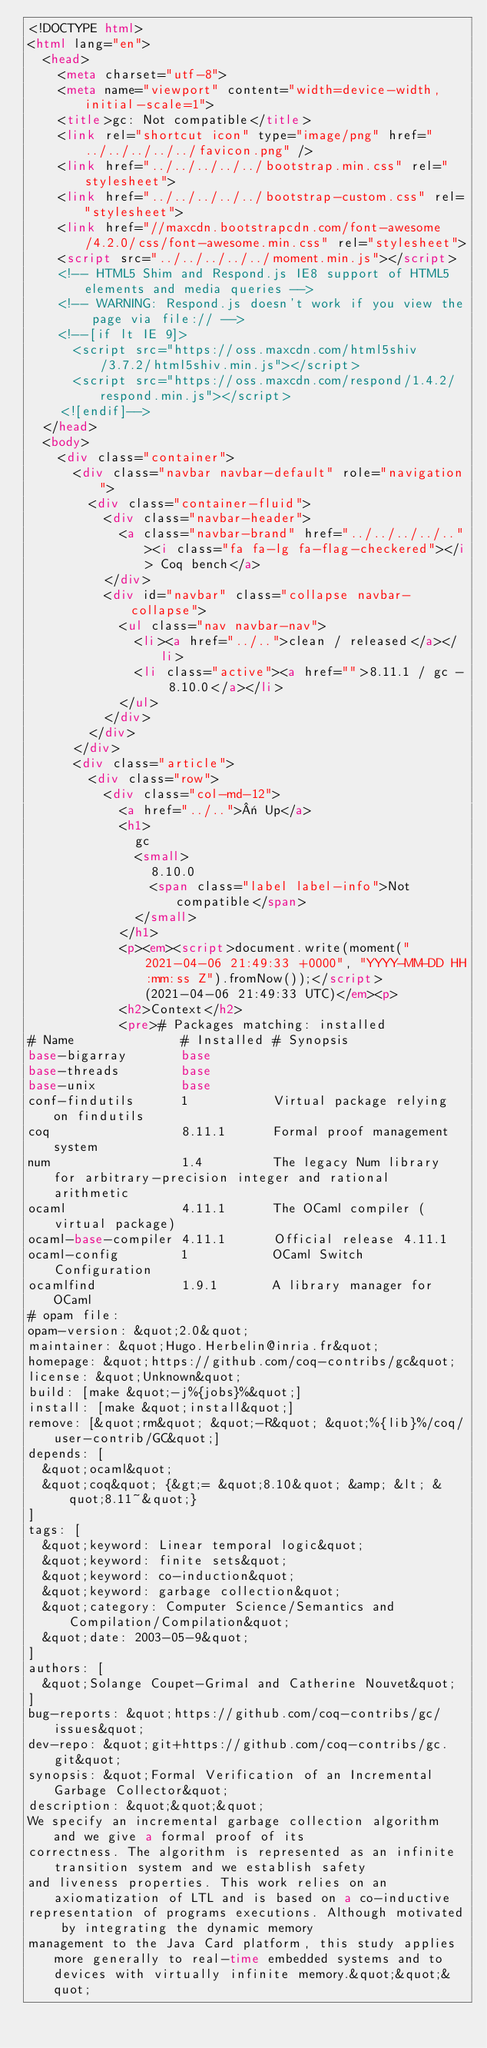<code> <loc_0><loc_0><loc_500><loc_500><_HTML_><!DOCTYPE html>
<html lang="en">
  <head>
    <meta charset="utf-8">
    <meta name="viewport" content="width=device-width, initial-scale=1">
    <title>gc: Not compatible</title>
    <link rel="shortcut icon" type="image/png" href="../../../../../favicon.png" />
    <link href="../../../../../bootstrap.min.css" rel="stylesheet">
    <link href="../../../../../bootstrap-custom.css" rel="stylesheet">
    <link href="//maxcdn.bootstrapcdn.com/font-awesome/4.2.0/css/font-awesome.min.css" rel="stylesheet">
    <script src="../../../../../moment.min.js"></script>
    <!-- HTML5 Shim and Respond.js IE8 support of HTML5 elements and media queries -->
    <!-- WARNING: Respond.js doesn't work if you view the page via file:// -->
    <!--[if lt IE 9]>
      <script src="https://oss.maxcdn.com/html5shiv/3.7.2/html5shiv.min.js"></script>
      <script src="https://oss.maxcdn.com/respond/1.4.2/respond.min.js"></script>
    <![endif]-->
  </head>
  <body>
    <div class="container">
      <div class="navbar navbar-default" role="navigation">
        <div class="container-fluid">
          <div class="navbar-header">
            <a class="navbar-brand" href="../../../../.."><i class="fa fa-lg fa-flag-checkered"></i> Coq bench</a>
          </div>
          <div id="navbar" class="collapse navbar-collapse">
            <ul class="nav navbar-nav">
              <li><a href="../..">clean / released</a></li>
              <li class="active"><a href="">8.11.1 / gc - 8.10.0</a></li>
            </ul>
          </div>
        </div>
      </div>
      <div class="article">
        <div class="row">
          <div class="col-md-12">
            <a href="../..">« Up</a>
            <h1>
              gc
              <small>
                8.10.0
                <span class="label label-info">Not compatible</span>
              </small>
            </h1>
            <p><em><script>document.write(moment("2021-04-06 21:49:33 +0000", "YYYY-MM-DD HH:mm:ss Z").fromNow());</script> (2021-04-06 21:49:33 UTC)</em><p>
            <h2>Context</h2>
            <pre># Packages matching: installed
# Name              # Installed # Synopsis
base-bigarray       base
base-threads        base
base-unix           base
conf-findutils      1           Virtual package relying on findutils
coq                 8.11.1      Formal proof management system
num                 1.4         The legacy Num library for arbitrary-precision integer and rational arithmetic
ocaml               4.11.1      The OCaml compiler (virtual package)
ocaml-base-compiler 4.11.1      Official release 4.11.1
ocaml-config        1           OCaml Switch Configuration
ocamlfind           1.9.1       A library manager for OCaml
# opam file:
opam-version: &quot;2.0&quot;
maintainer: &quot;Hugo.Herbelin@inria.fr&quot;
homepage: &quot;https://github.com/coq-contribs/gc&quot;
license: &quot;Unknown&quot;
build: [make &quot;-j%{jobs}%&quot;]
install: [make &quot;install&quot;]
remove: [&quot;rm&quot; &quot;-R&quot; &quot;%{lib}%/coq/user-contrib/GC&quot;]
depends: [
  &quot;ocaml&quot;
  &quot;coq&quot; {&gt;= &quot;8.10&quot; &amp; &lt; &quot;8.11~&quot;}
]
tags: [
  &quot;keyword: Linear temporal logic&quot;
  &quot;keyword: finite sets&quot;
  &quot;keyword: co-induction&quot;
  &quot;keyword: garbage collection&quot;
  &quot;category: Computer Science/Semantics and Compilation/Compilation&quot;
  &quot;date: 2003-05-9&quot;
]
authors: [
  &quot;Solange Coupet-Grimal and Catherine Nouvet&quot;
]
bug-reports: &quot;https://github.com/coq-contribs/gc/issues&quot;
dev-repo: &quot;git+https://github.com/coq-contribs/gc.git&quot;
synopsis: &quot;Formal Verification of an Incremental Garbage Collector&quot;
description: &quot;&quot;&quot;
We specify an incremental garbage collection algorithm and we give a formal proof of its
correctness. The algorithm is represented as an infinite transition system and we establish safety
and liveness properties. This work relies on an axiomatization of LTL and is based on a co-inductive
representation of programs executions. Although motivated by integrating the dynamic memory
management to the Java Card platform, this study applies more generally to real-time embedded systems and to devices with virtually infinite memory.&quot;&quot;&quot;</code> 